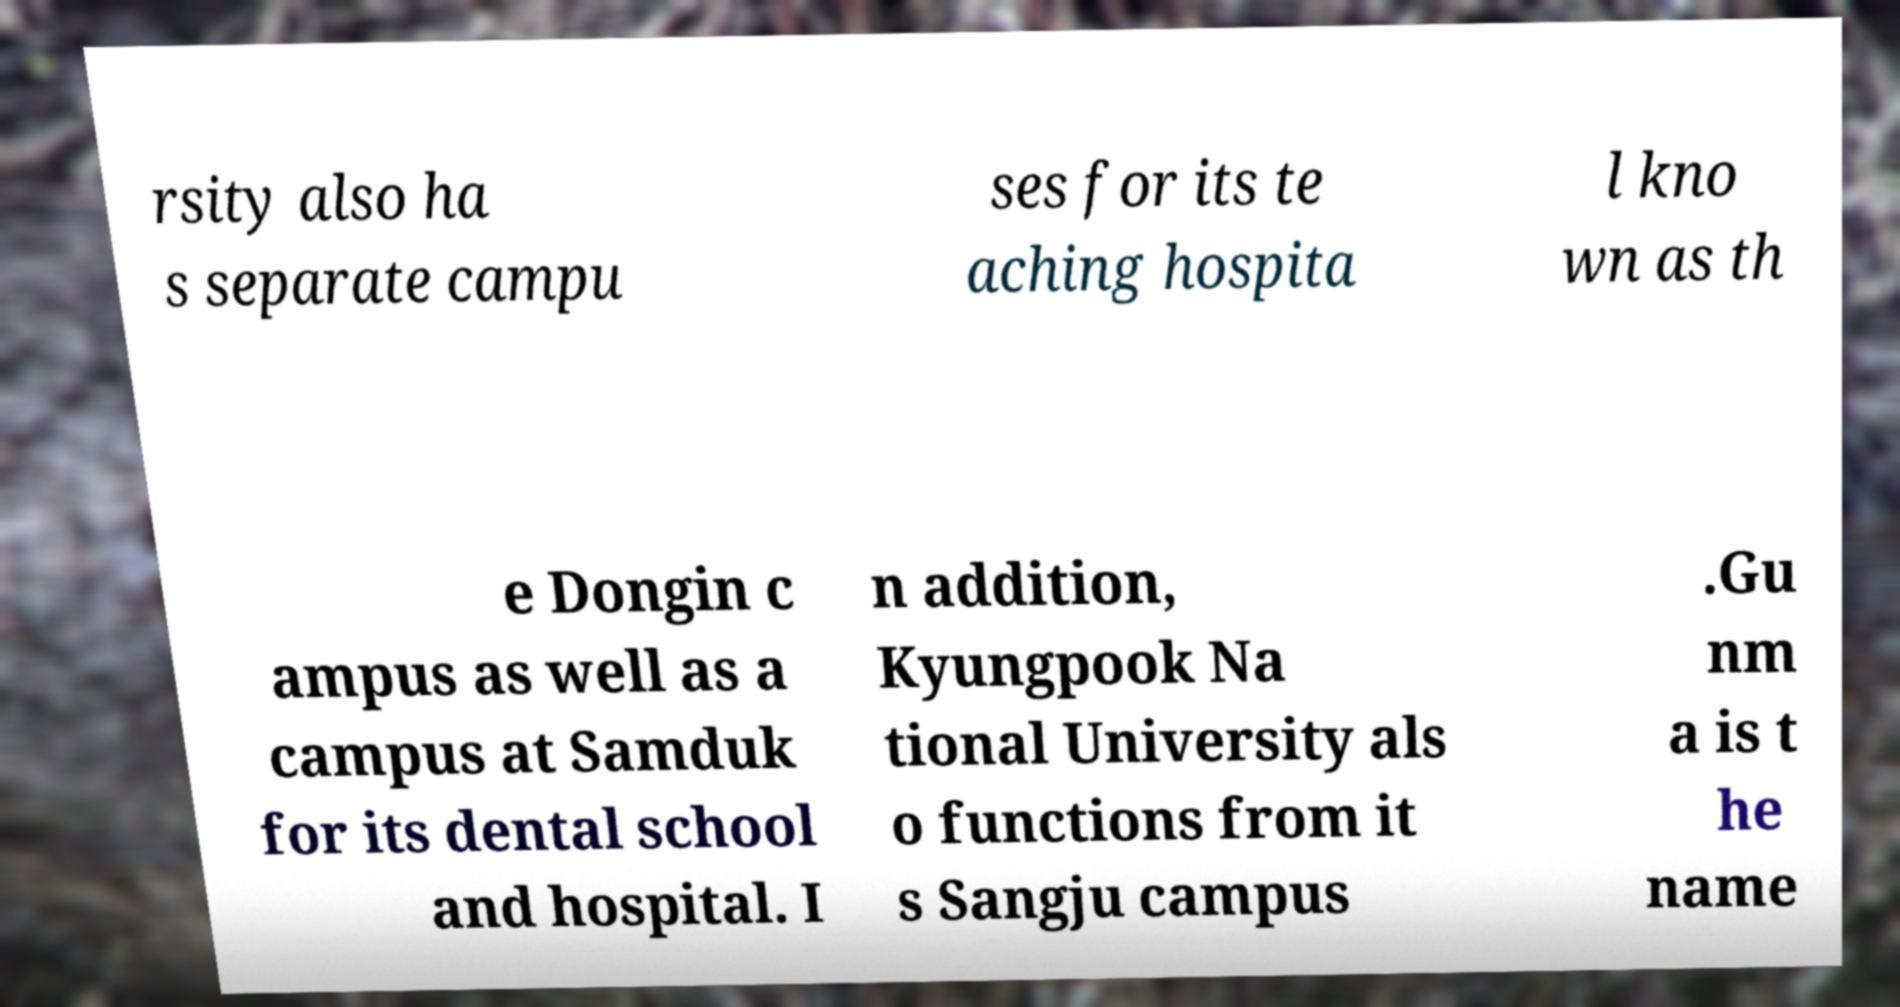Can you accurately transcribe the text from the provided image for me? rsity also ha s separate campu ses for its te aching hospita l kno wn as th e Dongin c ampus as well as a campus at Samduk for its dental school and hospital. I n addition, Kyungpook Na tional University als o functions from it s Sangju campus .Gu nm a is t he name 